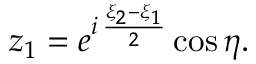<formula> <loc_0><loc_0><loc_500><loc_500>z _ { 1 } = e ^ { i \, { \frac { \xi _ { 2 } - \xi _ { 1 } } { 2 } } } \cos \eta .</formula> 